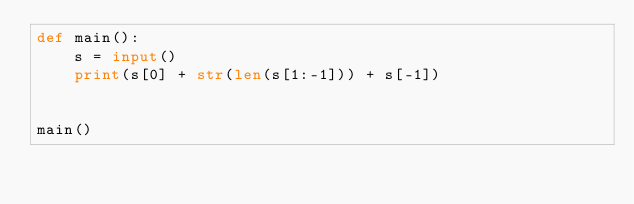<code> <loc_0><loc_0><loc_500><loc_500><_Python_>def main():
    s = input()
    print(s[0] + str(len(s[1:-1])) + s[-1])


main()
</code> 